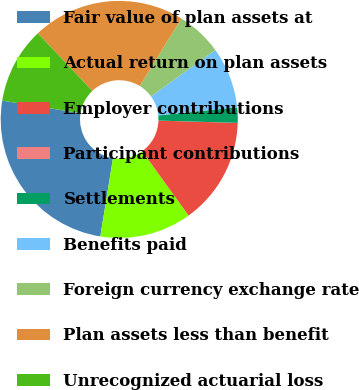Convert chart to OTSL. <chart><loc_0><loc_0><loc_500><loc_500><pie_chart><fcel>Fair value of plan assets at<fcel>Actual return on plan assets<fcel>Employer contributions<fcel>Participant contributions<fcel>Settlements<fcel>Benefits paid<fcel>Foreign currency exchange rate<fcel>Plan assets less than benefit<fcel>Unrecognized actuarial loss<nl><fcel>24.99%<fcel>12.5%<fcel>14.58%<fcel>0.01%<fcel>2.09%<fcel>8.34%<fcel>6.25%<fcel>20.83%<fcel>10.42%<nl></chart> 